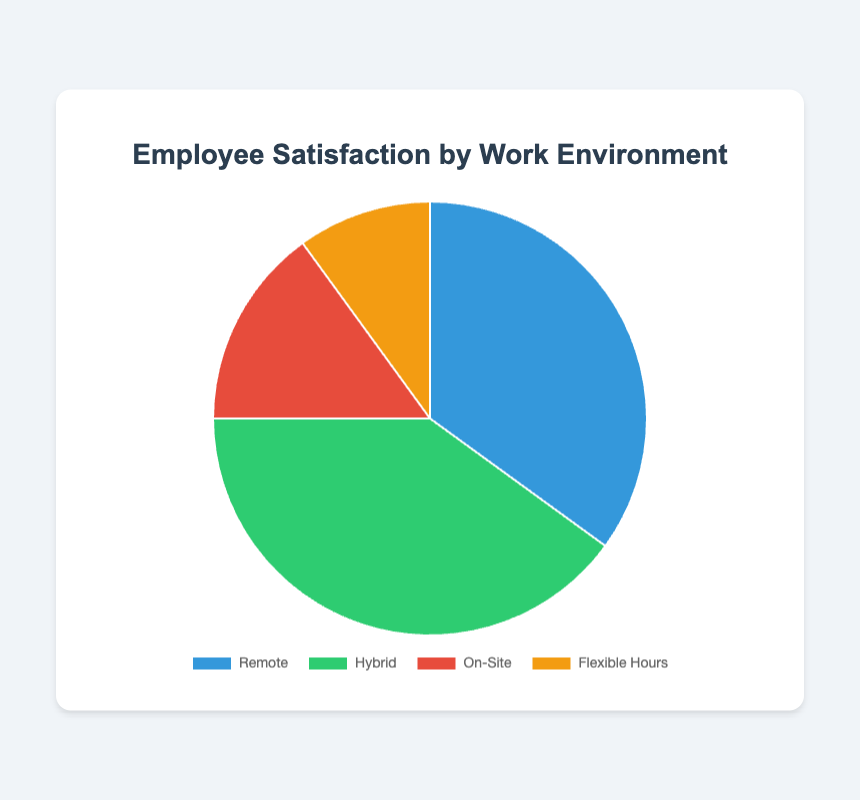What percentage of employees are satisfied with the remote work environment? The percentage is directly shown in the chart as a segment labeled "Remote", which is 35%.
Answer: 35% Which work environment has the highest percentage of employee satisfaction? By examining the pie chart, the segment labeled "Hybrid" has the largest portion, which is 40%.
Answer: Hybrid How much larger is the satisfaction percentage for Hybrid compared to On-Site? The satisfaction percentage for Hybrid is 40%, and for On-Site, it is 15%. The difference is 40% - 15% = 25%.
Answer: 25% What is the combined percentage of employees satisfied with either the Remote or Flexible Hours environments? The percentages for Remote and Flexible Hours segments are 35% and 10%, respectively. Adding these together gives 35% + 10% = 45%.
Answer: 45% Which two work environments have the smallest percentages of employee satisfaction? Examining the pie chart, the smallest segments are labeled "On-Site" (15%) and "Flexible Hours" (10%).
Answer: On-Site and Flexible Hours How much larger is the satisfaction percentage for Remote compared to Flexible Hours? The Remote satisfaction percentage is 35%, and for Flexible Hours, it is 10%. The difference is 35% - 10% = 25%.
Answer: 25% What percentage of employees are satisfied with traditional work environments (On-Site)? The percentage is directly shown in the chart as a segment labeled "On-Site", which is 15%.
Answer: 15% How much larger is the satisfaction percentage for Hybrid compared to Remote? The Hybrid satisfaction percentage is 40%, and the Remote satisfaction percentage is 35%. The difference is 40% - 35% = 5%.
Answer: 5% Which work environment has the lowest employee satisfaction, and what is this percentage? By examining the pie chart, the smallest segment is labeled "Flexible Hours", which has 10%.
Answer: Flexible Hours, 10% What is the total percentage of employees satisfied with work environments that include some remote work (Remote and Hybrid)? The percentages for Remote and Hybrid segments are 35% and 40%, respectively. Adding these together results in 35% + 40% = 75%.
Answer: 75% 